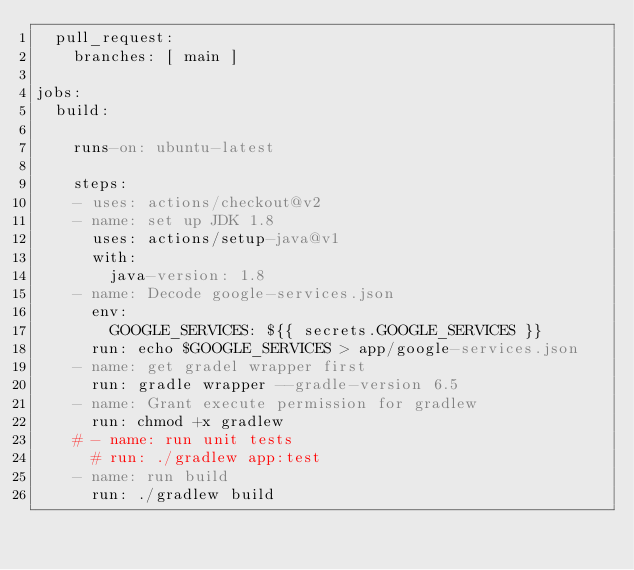<code> <loc_0><loc_0><loc_500><loc_500><_YAML_>  pull_request:
    branches: [ main ]

jobs:
  build:

    runs-on: ubuntu-latest

    steps:
    - uses: actions/checkout@v2
    - name: set up JDK 1.8
      uses: actions/setup-java@v1
      with:
        java-version: 1.8    
    - name: Decode google-services.json
      env:
        GOOGLE_SERVICES: ${{ secrets.GOOGLE_SERVICES }}
      run: echo $GOOGLE_SERVICES > app/google-services.json    
    - name: get gradel wrapper first
      run: gradle wrapper --gradle-version 6.5
    - name: Grant execute permission for gradlew
      run: chmod +x gradlew
    # - name: run unit tests
      # run: ./gradlew app:test
    - name: run build
      run: ./gradlew build
</code> 